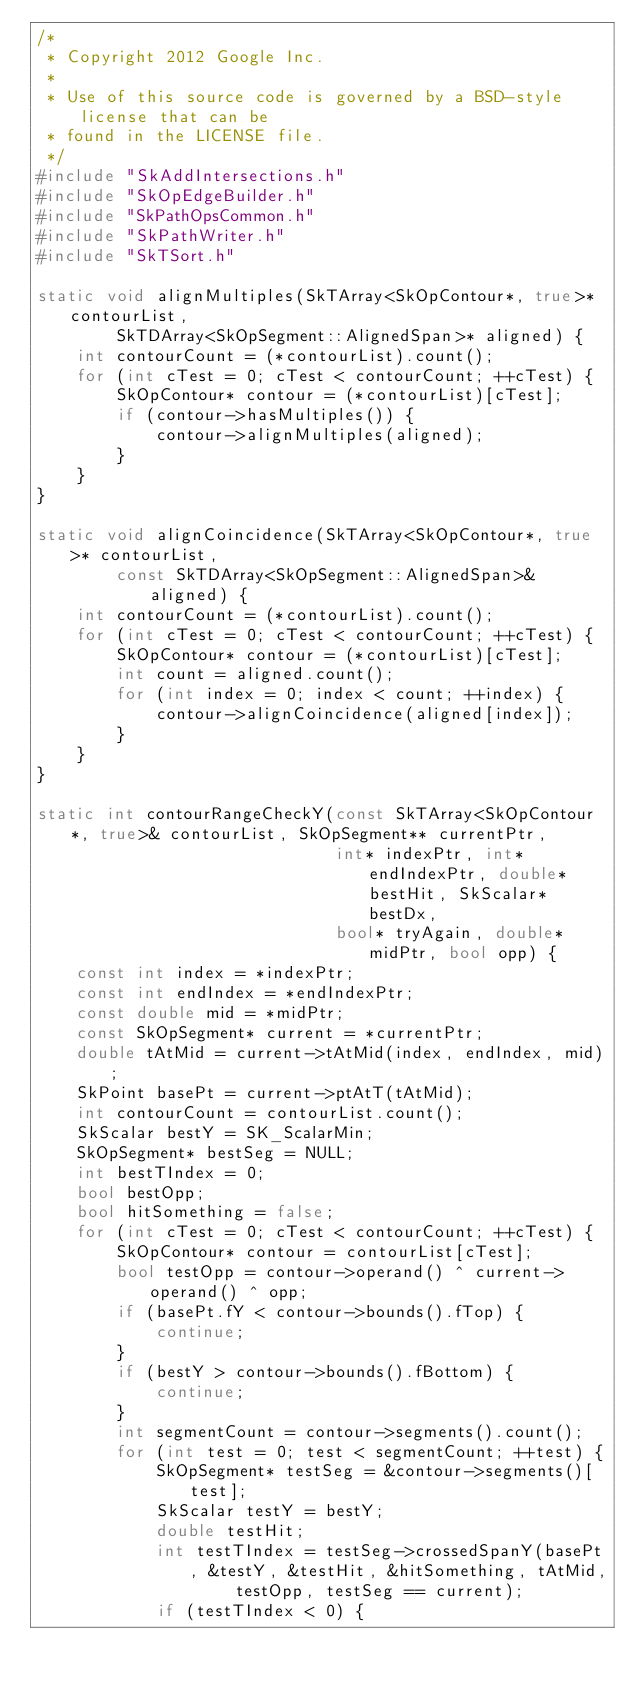<code> <loc_0><loc_0><loc_500><loc_500><_C++_>/*
 * Copyright 2012 Google Inc.
 *
 * Use of this source code is governed by a BSD-style license that can be
 * found in the LICENSE file.
 */
#include "SkAddIntersections.h"
#include "SkOpEdgeBuilder.h"
#include "SkPathOpsCommon.h"
#include "SkPathWriter.h"
#include "SkTSort.h"

static void alignMultiples(SkTArray<SkOpContour*, true>* contourList,
        SkTDArray<SkOpSegment::AlignedSpan>* aligned) {
    int contourCount = (*contourList).count();
    for (int cTest = 0; cTest < contourCount; ++cTest) {
        SkOpContour* contour = (*contourList)[cTest];
        if (contour->hasMultiples()) {
            contour->alignMultiples(aligned);
        }
    }
}

static void alignCoincidence(SkTArray<SkOpContour*, true>* contourList,
        const SkTDArray<SkOpSegment::AlignedSpan>& aligned) {
    int contourCount = (*contourList).count();
    for (int cTest = 0; cTest < contourCount; ++cTest) {
        SkOpContour* contour = (*contourList)[cTest];
        int count = aligned.count();
        for (int index = 0; index < count; ++index) {
            contour->alignCoincidence(aligned[index]);
        }
    }    
}

static int contourRangeCheckY(const SkTArray<SkOpContour*, true>& contourList, SkOpSegment** currentPtr,
                              int* indexPtr, int* endIndexPtr, double* bestHit, SkScalar* bestDx,
                              bool* tryAgain, double* midPtr, bool opp) {
    const int index = *indexPtr;
    const int endIndex = *endIndexPtr;
    const double mid = *midPtr;
    const SkOpSegment* current = *currentPtr;
    double tAtMid = current->tAtMid(index, endIndex, mid);
    SkPoint basePt = current->ptAtT(tAtMid);
    int contourCount = contourList.count();
    SkScalar bestY = SK_ScalarMin;
    SkOpSegment* bestSeg = NULL;
    int bestTIndex = 0;
    bool bestOpp;
    bool hitSomething = false;
    for (int cTest = 0; cTest < contourCount; ++cTest) {
        SkOpContour* contour = contourList[cTest];
        bool testOpp = contour->operand() ^ current->operand() ^ opp;
        if (basePt.fY < contour->bounds().fTop) {
            continue;
        }
        if (bestY > contour->bounds().fBottom) {
            continue;
        }
        int segmentCount = contour->segments().count();
        for (int test = 0; test < segmentCount; ++test) {
            SkOpSegment* testSeg = &contour->segments()[test];
            SkScalar testY = bestY;
            double testHit;
            int testTIndex = testSeg->crossedSpanY(basePt, &testY, &testHit, &hitSomething, tAtMid,
                    testOpp, testSeg == current);
            if (testTIndex < 0) {</code> 